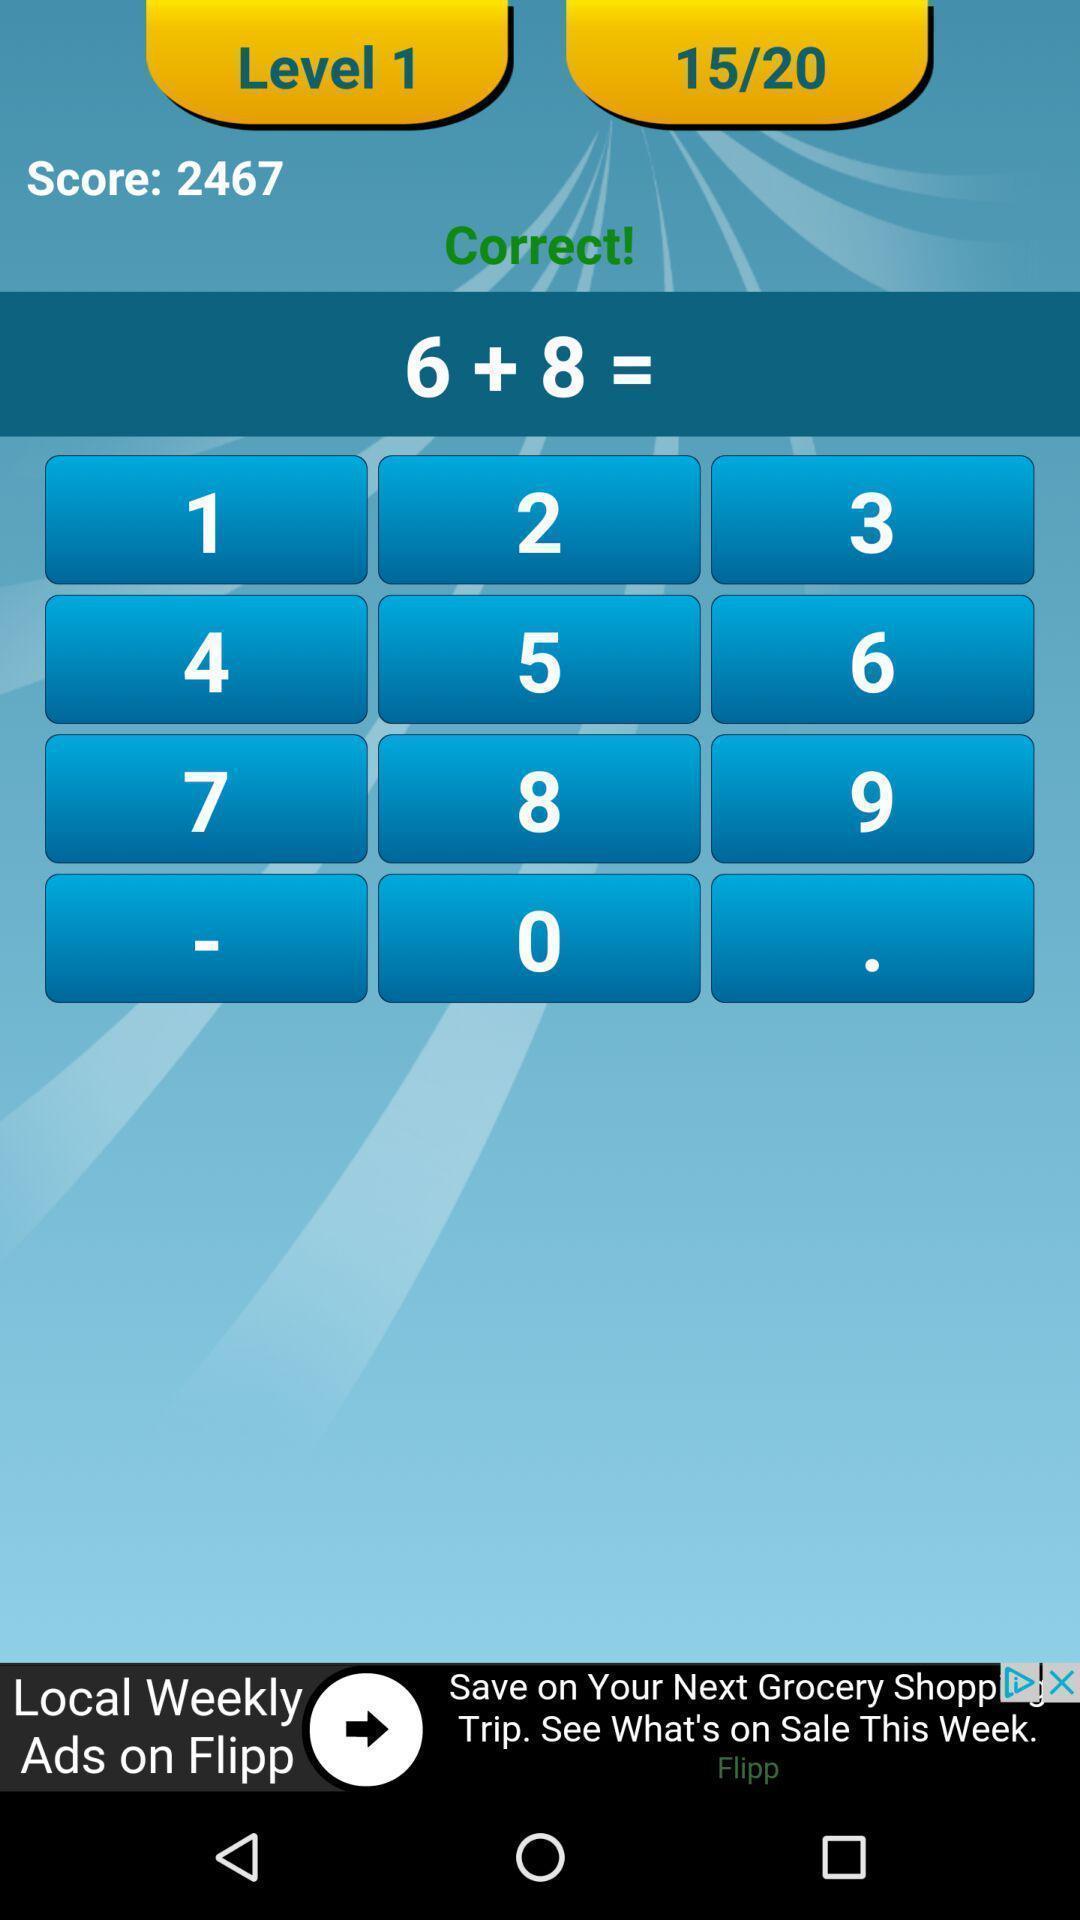Describe the content in this image. Page displaying the score and sum. 